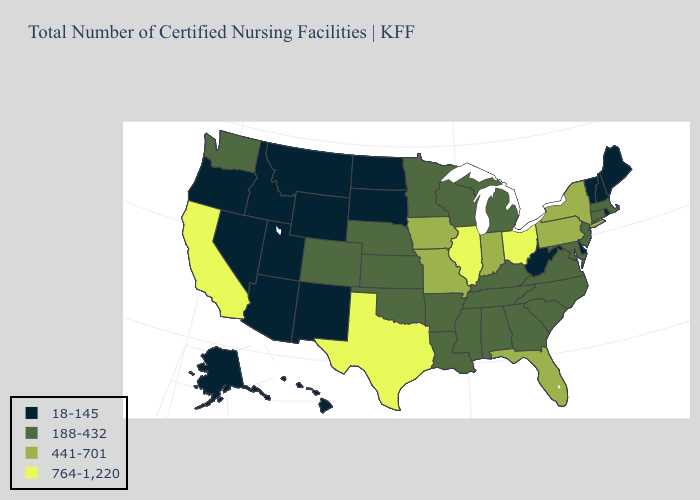What is the value of Rhode Island?
Keep it brief. 18-145. Which states have the lowest value in the Northeast?
Write a very short answer. Maine, New Hampshire, Rhode Island, Vermont. Does the first symbol in the legend represent the smallest category?
Write a very short answer. Yes. Does Maine have a lower value than Oregon?
Answer briefly. No. What is the highest value in the USA?
Quick response, please. 764-1,220. What is the highest value in states that border Iowa?
Concise answer only. 764-1,220. What is the value of Indiana?
Concise answer only. 441-701. What is the value of Indiana?
Answer briefly. 441-701. What is the highest value in the USA?
Answer briefly. 764-1,220. Among the states that border Wisconsin , which have the lowest value?
Write a very short answer. Michigan, Minnesota. Does Nevada have a lower value than Indiana?
Be succinct. Yes. What is the value of Wisconsin?
Answer briefly. 188-432. Name the states that have a value in the range 764-1,220?
Concise answer only. California, Illinois, Ohio, Texas. Does Texas have the highest value in the South?
Quick response, please. Yes. 